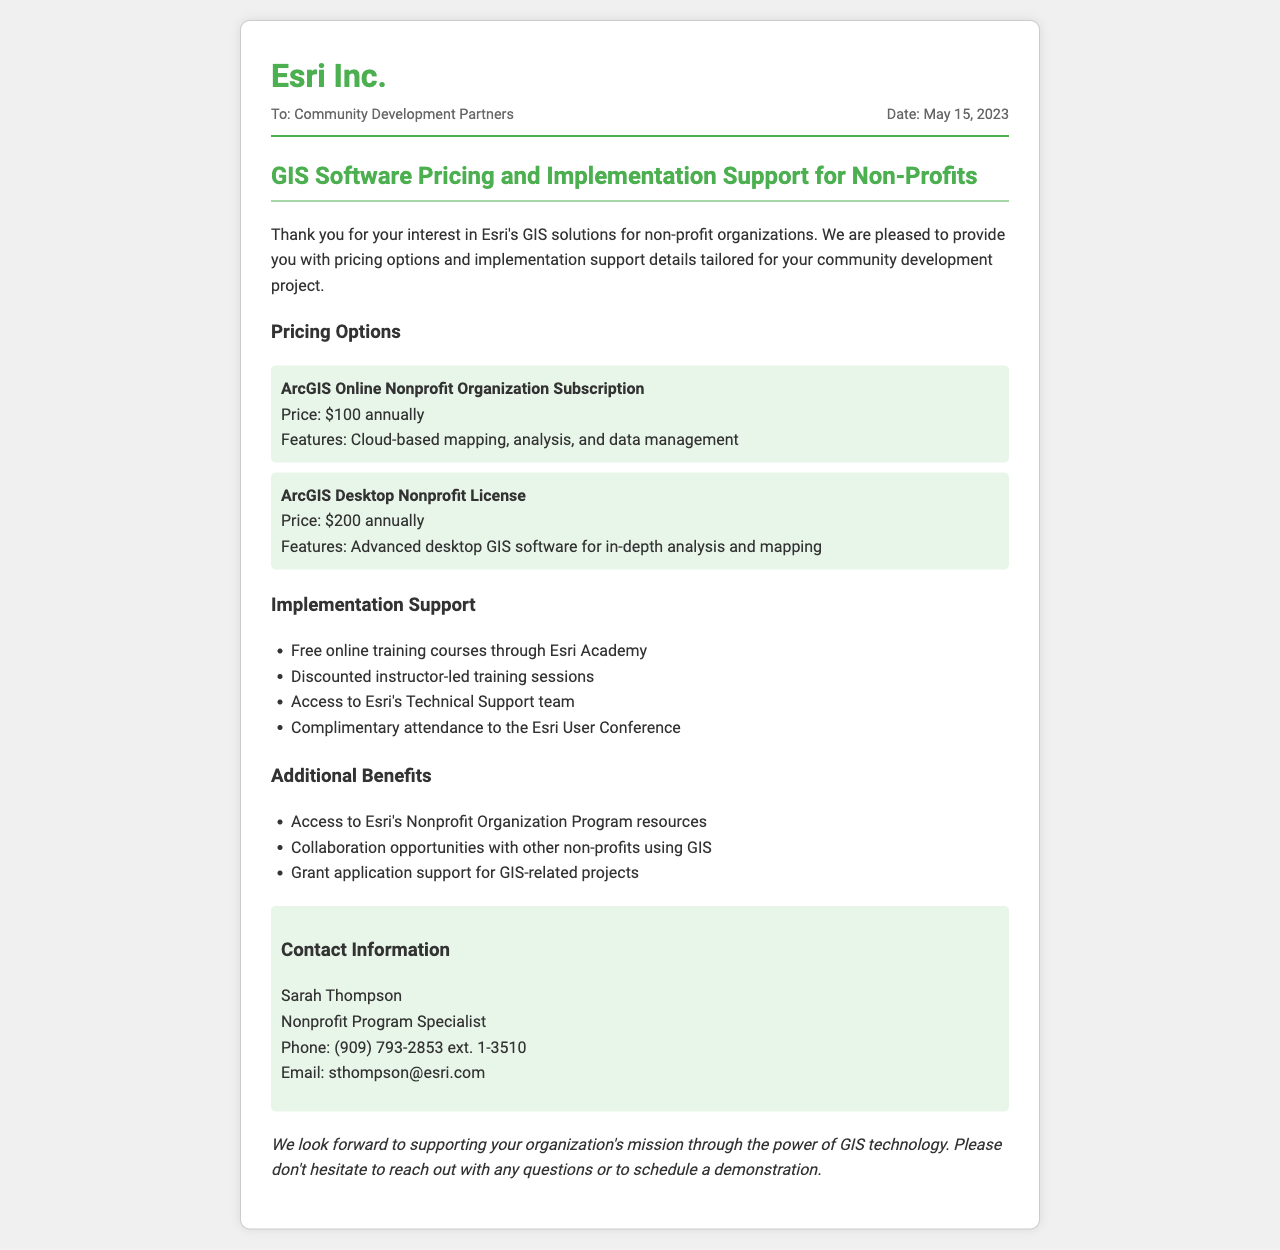What is the name of the company providing GIS solutions? The company providing GIS solutions is stated in the header of the document.
Answer: Esri Inc What is the price for the ArcGIS Online Nonprofit Organization Subscription? The price for the subscription is listed under the pricing options section.
Answer: $100 annually Who is the contact person for inquiries? The contact person is mentioned in the contact information section of the fax.
Answer: Sarah Thompson What type of training is offered for free? The type of training mentioned under implementation support that is free is online training courses.
Answer: Free online training courses What is one of the additional benefits noted in the document? The additional benefits section lists various opportunities and resources available, one of them can be retrieved.
Answer: Access to Esri's Nonprofit Organization Program resources What date was the fax sent? The date of sending the fax is mentioned in the subheader right below the recipient's information.
Answer: May 15, 2023 How much is the price for the ArcGIS Desktop Nonprofit License? The price is provided alongside the features of the license in the pricing options section.
Answer: $200 annually What is one of the features of the ArcGIS Desktop Nonprofit License? The features of this license are listed alongside its price in the pricing options.
Answer: Advanced desktop GIS software for in-depth analysis and mapping What is offered at a discounted rate according to the implementation support section? The implementation support section mentions this specifically regarding training types.
Answer: Discounted instructor-led training sessions 